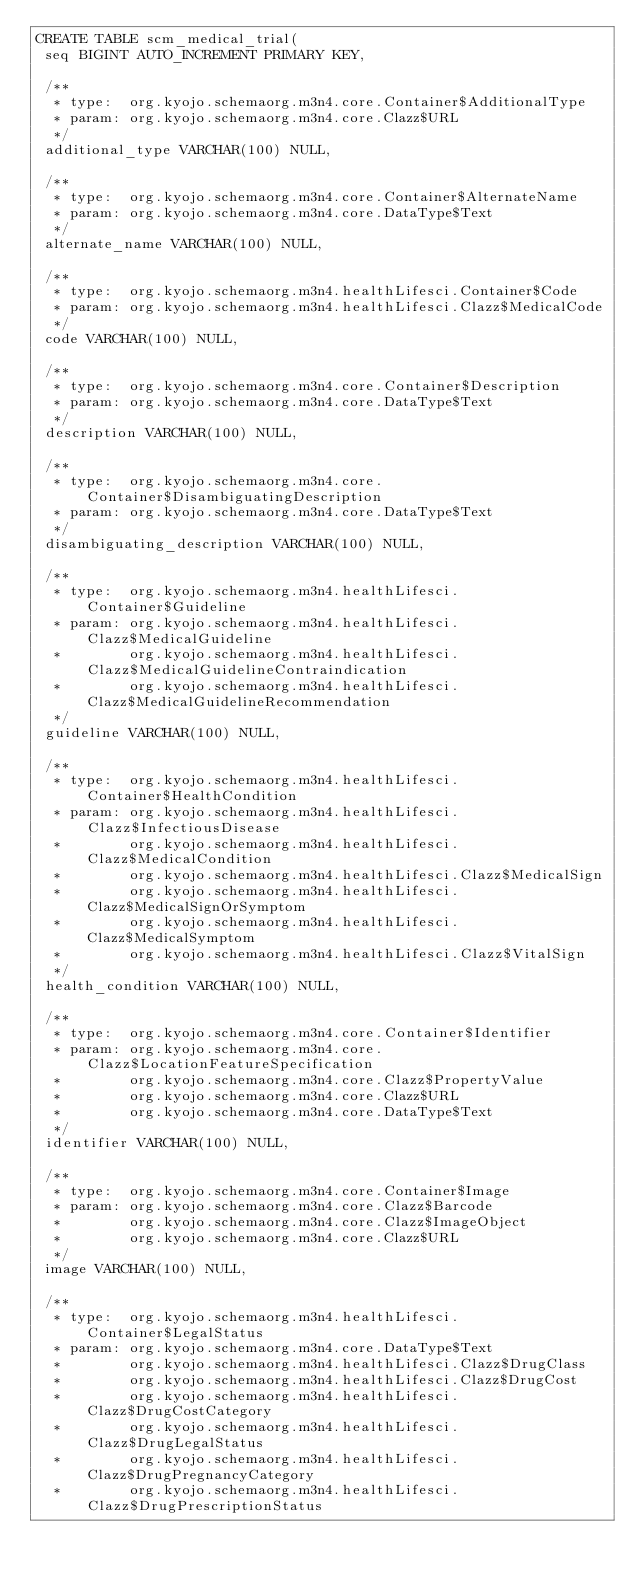Convert code to text. <code><loc_0><loc_0><loc_500><loc_500><_SQL_>CREATE TABLE scm_medical_trial(
 seq BIGINT AUTO_INCREMENT PRIMARY KEY,

 /**
  * type:  org.kyojo.schemaorg.m3n4.core.Container$AdditionalType
  * param: org.kyojo.schemaorg.m3n4.core.Clazz$URL
  */
 additional_type VARCHAR(100) NULL,

 /**
  * type:  org.kyojo.schemaorg.m3n4.core.Container$AlternateName
  * param: org.kyojo.schemaorg.m3n4.core.DataType$Text
  */
 alternate_name VARCHAR(100) NULL,

 /**
  * type:  org.kyojo.schemaorg.m3n4.healthLifesci.Container$Code
  * param: org.kyojo.schemaorg.m3n4.healthLifesci.Clazz$MedicalCode
  */
 code VARCHAR(100) NULL,

 /**
  * type:  org.kyojo.schemaorg.m3n4.core.Container$Description
  * param: org.kyojo.schemaorg.m3n4.core.DataType$Text
  */
 description VARCHAR(100) NULL,

 /**
  * type:  org.kyojo.schemaorg.m3n4.core.Container$DisambiguatingDescription
  * param: org.kyojo.schemaorg.m3n4.core.DataType$Text
  */
 disambiguating_description VARCHAR(100) NULL,

 /**
  * type:  org.kyojo.schemaorg.m3n4.healthLifesci.Container$Guideline
  * param: org.kyojo.schemaorg.m3n4.healthLifesci.Clazz$MedicalGuideline
  *        org.kyojo.schemaorg.m3n4.healthLifesci.Clazz$MedicalGuidelineContraindication
  *        org.kyojo.schemaorg.m3n4.healthLifesci.Clazz$MedicalGuidelineRecommendation
  */
 guideline VARCHAR(100) NULL,

 /**
  * type:  org.kyojo.schemaorg.m3n4.healthLifesci.Container$HealthCondition
  * param: org.kyojo.schemaorg.m3n4.healthLifesci.Clazz$InfectiousDisease
  *        org.kyojo.schemaorg.m3n4.healthLifesci.Clazz$MedicalCondition
  *        org.kyojo.schemaorg.m3n4.healthLifesci.Clazz$MedicalSign
  *        org.kyojo.schemaorg.m3n4.healthLifesci.Clazz$MedicalSignOrSymptom
  *        org.kyojo.schemaorg.m3n4.healthLifesci.Clazz$MedicalSymptom
  *        org.kyojo.schemaorg.m3n4.healthLifesci.Clazz$VitalSign
  */
 health_condition VARCHAR(100) NULL,

 /**
  * type:  org.kyojo.schemaorg.m3n4.core.Container$Identifier
  * param: org.kyojo.schemaorg.m3n4.core.Clazz$LocationFeatureSpecification
  *        org.kyojo.schemaorg.m3n4.core.Clazz$PropertyValue
  *        org.kyojo.schemaorg.m3n4.core.Clazz$URL
  *        org.kyojo.schemaorg.m3n4.core.DataType$Text
  */
 identifier VARCHAR(100) NULL,

 /**
  * type:  org.kyojo.schemaorg.m3n4.core.Container$Image
  * param: org.kyojo.schemaorg.m3n4.core.Clazz$Barcode
  *        org.kyojo.schemaorg.m3n4.core.Clazz$ImageObject
  *        org.kyojo.schemaorg.m3n4.core.Clazz$URL
  */
 image VARCHAR(100) NULL,

 /**
  * type:  org.kyojo.schemaorg.m3n4.healthLifesci.Container$LegalStatus
  * param: org.kyojo.schemaorg.m3n4.core.DataType$Text
  *        org.kyojo.schemaorg.m3n4.healthLifesci.Clazz$DrugClass
  *        org.kyojo.schemaorg.m3n4.healthLifesci.Clazz$DrugCost
  *        org.kyojo.schemaorg.m3n4.healthLifesci.Clazz$DrugCostCategory
  *        org.kyojo.schemaorg.m3n4.healthLifesci.Clazz$DrugLegalStatus
  *        org.kyojo.schemaorg.m3n4.healthLifesci.Clazz$DrugPregnancyCategory
  *        org.kyojo.schemaorg.m3n4.healthLifesci.Clazz$DrugPrescriptionStatus</code> 